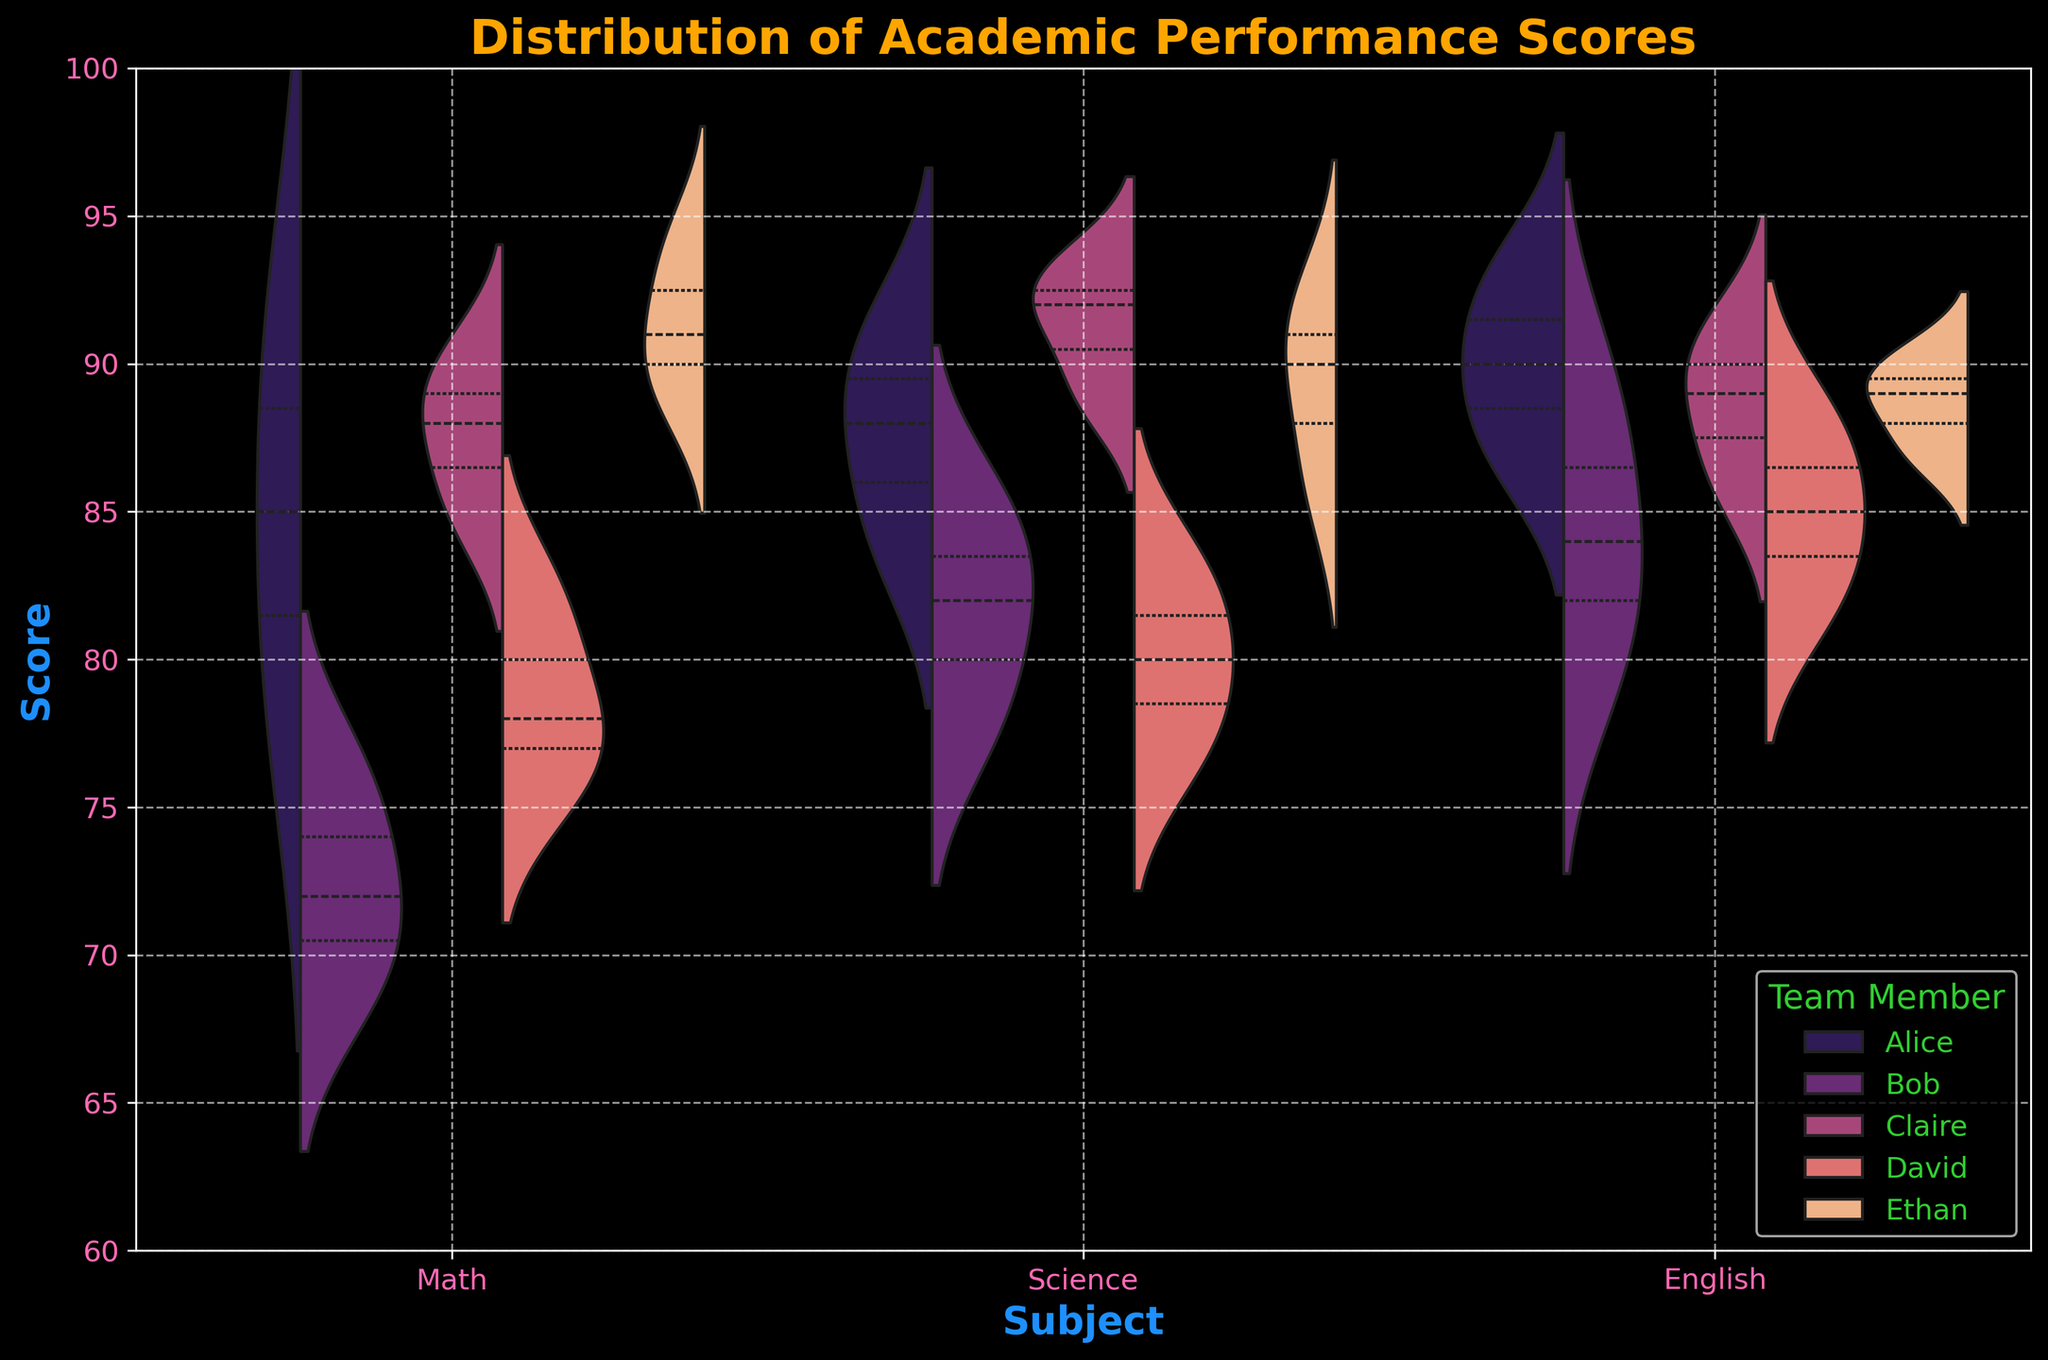Which subject has the highest score range for Alice? To find out the subject with the highest score range for Alice, look at the span of the violins for Alice across different subjects. Each violin represents the distribution of scores, and the wider the span, the more variability it covers. For Alice, Science shows the highest range.
Answer: Science Which team member has the tightest English score distribution? To determine which team member has the tightest English score distribution, check each violin plot for English and compare the spreads. A tighter spread indicates less variation. For English, David shows the tightest spread.
Answer: David Whose Math scores show the highest variability? To identify who has the highest variability in Math scores, look at the width of the Math violin plots for each team member. Wider distributions indicate higher variability. Ethan's Math scores show the highest variability.
Answer: Ethan What is the overall median score for Science? To find the overall median score for Science, refer to the median lines shown within the violins. The median line is generally located in the thicker part of the violin. For Science, the median score appears to be around 88.
Answer: 88 Which subject has the smallest interquartile range (IQR) for Claire? To find the smallest interquartile range for Claire, compare the thickness of the sections within the violins representing the middle 50% of the data. The tighter the section, the smaller the IQR. Claire's English scores have the smallest IQR.
Answer: English In which subject do all team members show scores above 70? To verify the subjects with all scores above 70, analyze the lower tails of the violin plots. If the lower end stays above 70 for each team member, then all scores in that subject are above 70. All team members have scores above 70 in Science.
Answer: Science What is the highest score achieved in English? To determine the highest score in English, refer to the topmost part of the violin plots for the English subject. The highest point in these violins represents the highest score. The highest score in English is 93, achieved by Alice.
Answer: 93 Which team member has the most consistent scores across all subjects? To identify the team member with the most consistent scores, compare the overall span of all violins for each team member across subjects. The one with the smallest span in all subjects has the most consistent scores. David has the most consistent scores across all subjects.
Answer: David What is the median score of Ethan in Math? To find Ethan's median score in Math, locate the median line within the Math violin for Ethan. The median line is the dashed line inside the plots. Ethan's median score in Math is around 91.
Answer: 91 